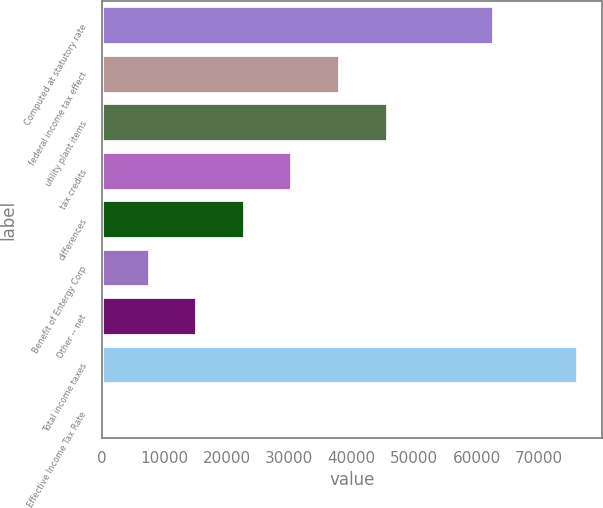Convert chart. <chart><loc_0><loc_0><loc_500><loc_500><bar_chart><fcel>Computed at statutory rate<fcel>federal income tax effect<fcel>utility plant items<fcel>tax credits<fcel>differences<fcel>Benefit of Entergy Corp<fcel>Other -- net<fcel>Total income taxes<fcel>Effective Income Tax Rate<nl><fcel>62836<fcel>38109.7<fcel>45723.2<fcel>30496.2<fcel>22882.8<fcel>7655.86<fcel>15269.3<fcel>76177<fcel>42.4<nl></chart> 